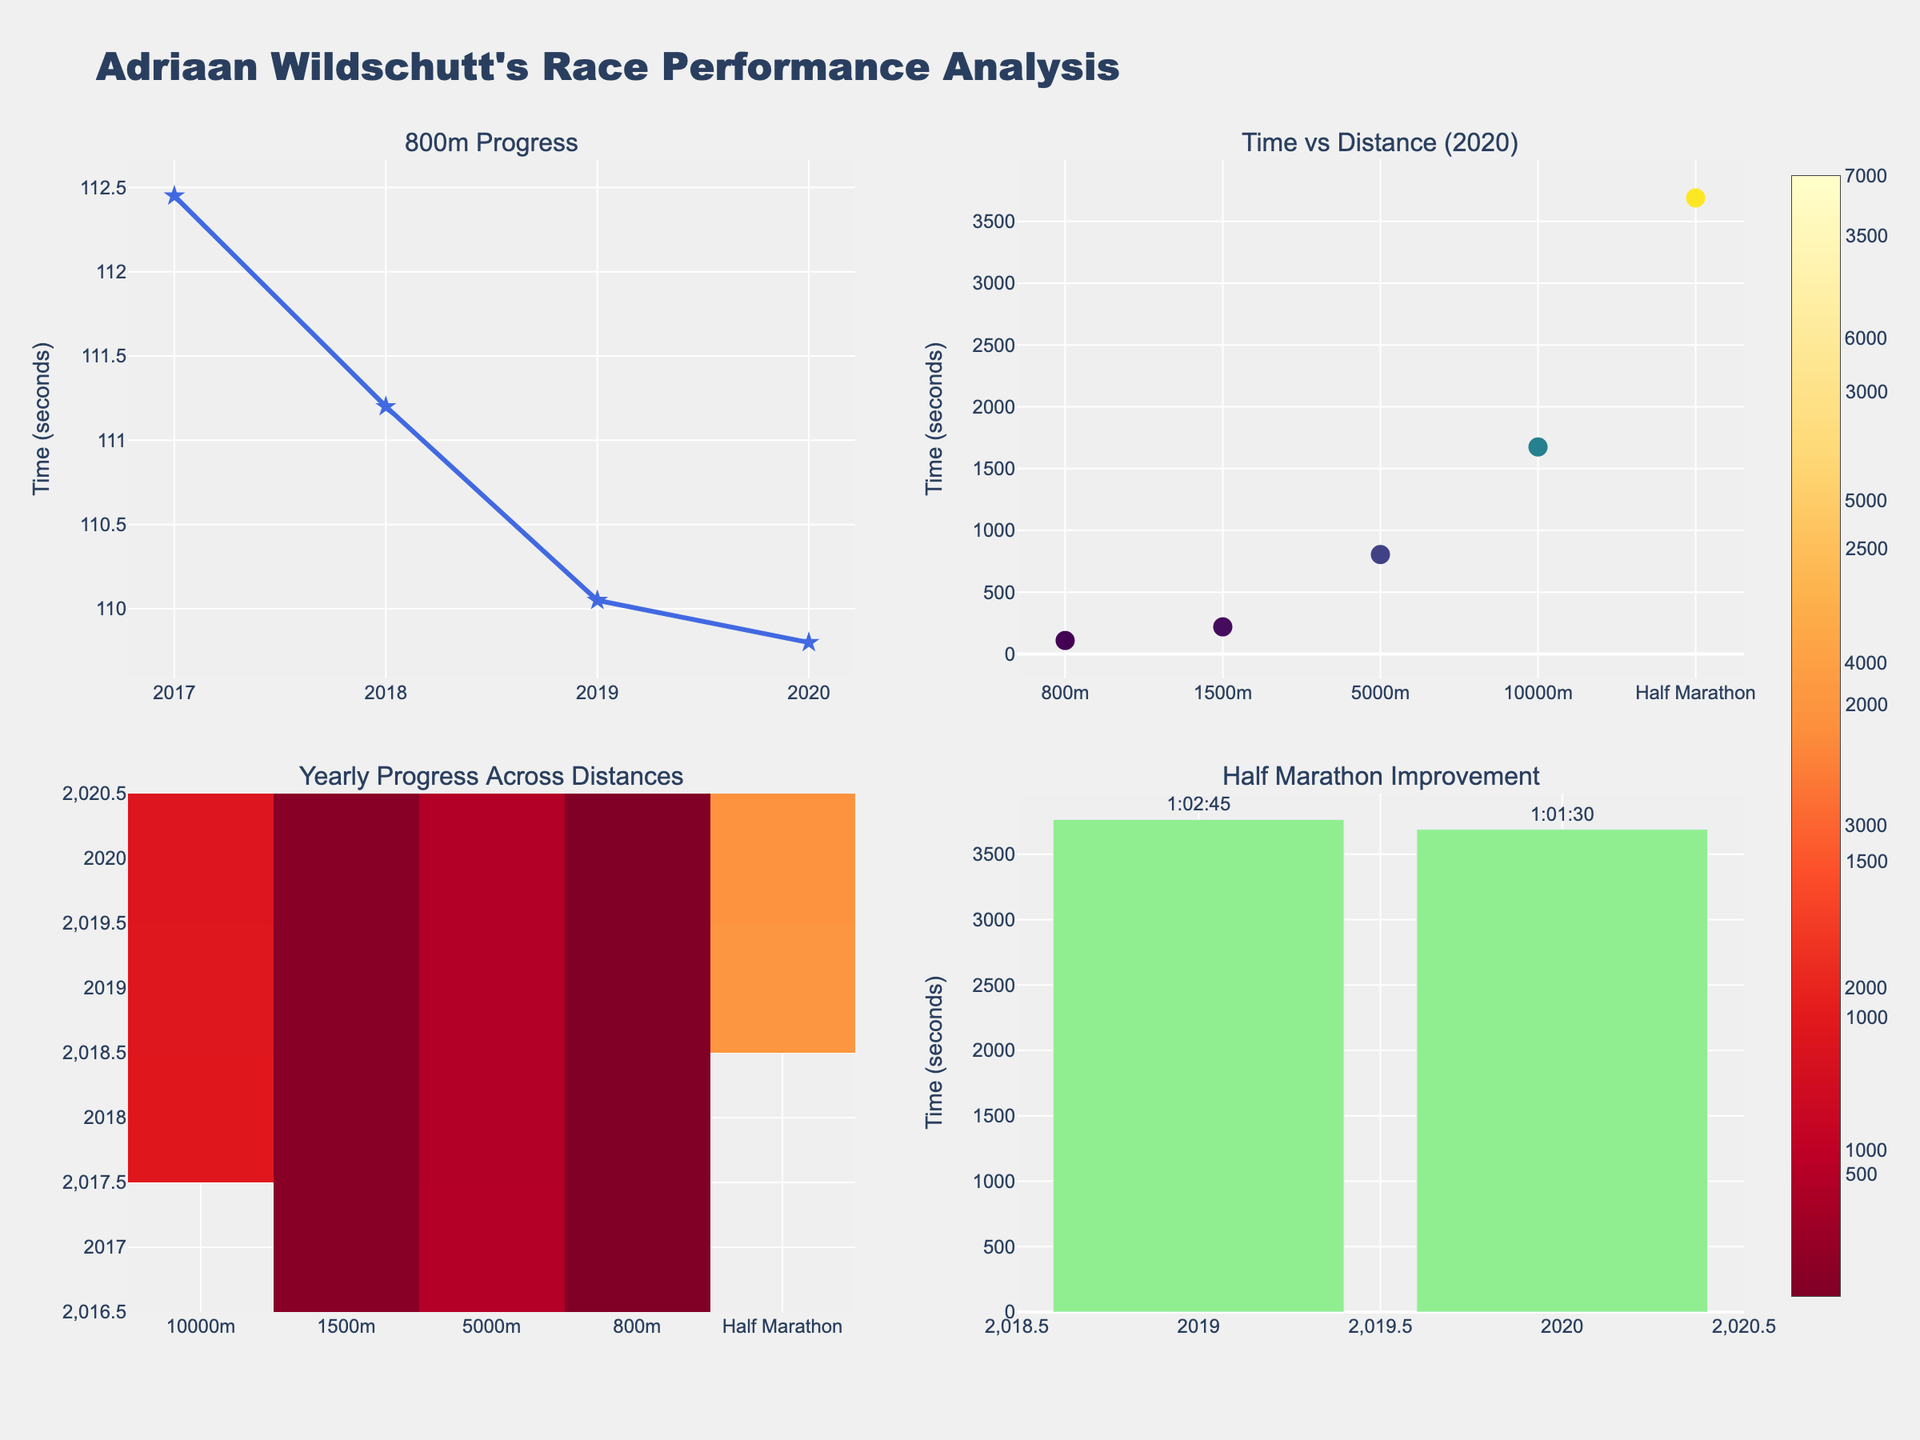Which social media platform has the highest number of daily active users? Looking at the upper subplot titled "Daily Active Users," we see that YouTube and WhatsApp each have 2000 million daily active users, making them the highest.
Answer: YouTube and WhatsApp Which platform has the lowest average time spent per session? In the lower subplot titled "Average Time Spent per Session," Pinterest has the lowest value at 14 minutes.
Answer: Pinterest What is the difference in daily active users between Facebook and TikTok? From the upper subplot, Facebook has 1900 million daily active users, and TikTok has 800 million. The difference is 1900 - 800 = 1100 million.
Answer: 1100 million Which two platforms have a similar number of daily active users, and what are their values? By visually comparing the bar heights in the upper subplot, Reddit (52 million) and LinkedIn (310 million) seem similar. However, this comparison reveals Snapchat (375 million) and Twitter (396 million) are more alike.
Answer: Snapchat and Twitter with values around 375 and 396 million, respectively Which platform has the highest average time spent per session, and how much is it? The lower subplot shows that TikTok has the highest average time spent per session at 89 minutes.
Answer: TikTok, 89 minutes How many platforms have daily active users exceeding 1000 million? By counting the bars in the upper subplot that exceed the 1000 million mark, the platforms are Facebook, Instagram, YouTube, and WhatsApp, totaling 4 platforms.
Answer: 4 platforms What's the total number of daily active users for the top three platforms? The top three platforms by daily active users are YouTube and WhatsApp (2000 million each), and Facebook (1900 million). Summing these: 2000 + 2000 + 1900 = 5900 million.
Answer: 5900 million Which platform has a higher average time spent per session, Instagram or Snapchat, and by how much? Checking the lower subplot, Instagram's value is 53 minutes, and Snapchat's is 49 minutes. The difference is 53 - 49 = 4 minutes.
Answer: Instagram by 4 minutes What is the combined average time spent per session for Twitter and LinkedIn? The lower subplot shows Twitter at 31 minutes and LinkedIn at 29 minutes. Their combined average is 31 + 29 = 60 minutes.
Answer: 60 minutes Which platform has a greater number of daily active users, Reddit or Pinterest, and by how much? From the upper subplot, Pinterest has 431 million and Reddit has 52 million daily active users. The difference is 431 - 52 = 379 million.
Answer: Pinterest by 379 million 